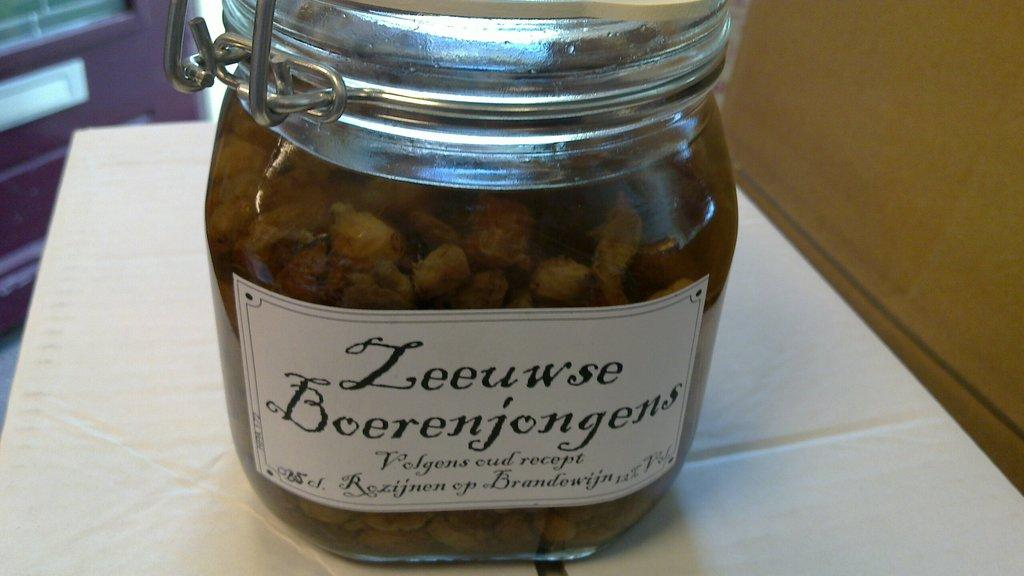Provide a one-sentence caption for the provided image. a jar of Zeeuswe Boerenjongens filled to the brim. 